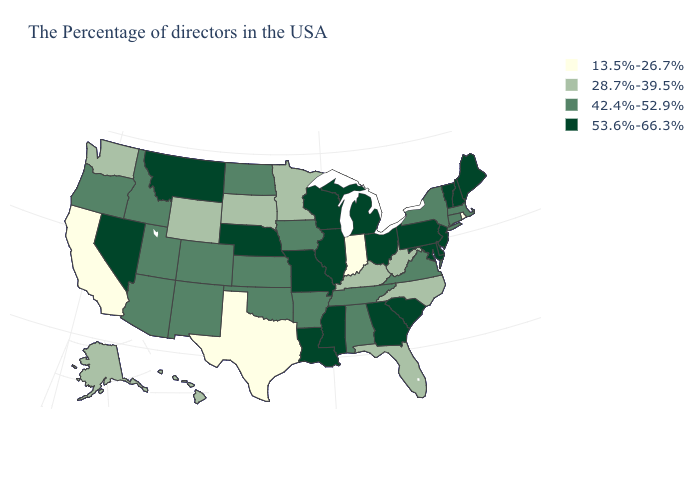What is the lowest value in the USA?
Quick response, please. 13.5%-26.7%. What is the value of New Hampshire?
Quick response, please. 53.6%-66.3%. Does Wisconsin have the highest value in the USA?
Give a very brief answer. Yes. Among the states that border Tennessee , which have the lowest value?
Concise answer only. North Carolina, Kentucky. Does the first symbol in the legend represent the smallest category?
Answer briefly. Yes. What is the value of Texas?
Quick response, please. 13.5%-26.7%. Name the states that have a value in the range 28.7%-39.5%?
Be succinct. North Carolina, West Virginia, Florida, Kentucky, Minnesota, South Dakota, Wyoming, Washington, Alaska, Hawaii. Does Connecticut have the lowest value in the Northeast?
Short answer required. No. Among the states that border Texas , does New Mexico have the highest value?
Be succinct. No. Name the states that have a value in the range 42.4%-52.9%?
Quick response, please. Massachusetts, Connecticut, New York, Virginia, Alabama, Tennessee, Arkansas, Iowa, Kansas, Oklahoma, North Dakota, Colorado, New Mexico, Utah, Arizona, Idaho, Oregon. Name the states that have a value in the range 53.6%-66.3%?
Concise answer only. Maine, New Hampshire, Vermont, New Jersey, Delaware, Maryland, Pennsylvania, South Carolina, Ohio, Georgia, Michigan, Wisconsin, Illinois, Mississippi, Louisiana, Missouri, Nebraska, Montana, Nevada. Name the states that have a value in the range 42.4%-52.9%?
Give a very brief answer. Massachusetts, Connecticut, New York, Virginia, Alabama, Tennessee, Arkansas, Iowa, Kansas, Oklahoma, North Dakota, Colorado, New Mexico, Utah, Arizona, Idaho, Oregon. Name the states that have a value in the range 42.4%-52.9%?
Short answer required. Massachusetts, Connecticut, New York, Virginia, Alabama, Tennessee, Arkansas, Iowa, Kansas, Oklahoma, North Dakota, Colorado, New Mexico, Utah, Arizona, Idaho, Oregon. Which states have the lowest value in the West?
Concise answer only. California. 